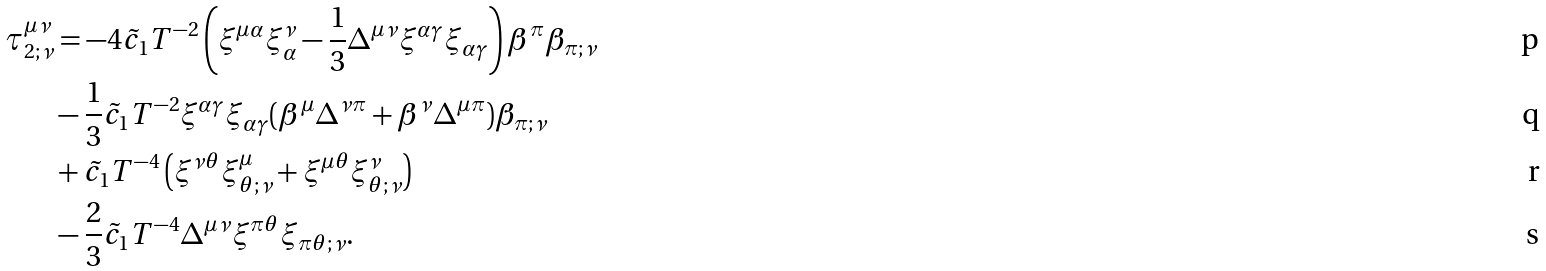<formula> <loc_0><loc_0><loc_500><loc_500>\tau _ { 2 ; \nu } ^ { \mu \nu } & = - 4 \tilde { c } _ { 1 } T ^ { - 2 } \left ( \xi ^ { \mu \alpha } \xi ^ { \nu } _ { \alpha } - \frac { 1 } { 3 } \Delta ^ { \mu \nu } \xi ^ { \alpha \gamma } \xi _ { \alpha \gamma } \right ) \beta ^ { \pi } \beta _ { \pi ; \nu } \\ & - \frac { 1 } { 3 } \tilde { c } _ { 1 } T ^ { - 2 } \xi ^ { \alpha \gamma } \xi _ { \alpha \gamma } ( \beta ^ { \mu } \Delta ^ { \nu \pi } + \beta ^ { \nu } \Delta ^ { \mu \pi } ) \beta _ { \pi ; \nu } \\ & + \tilde { c } _ { 1 } T ^ { - 4 } \left ( \xi ^ { \nu \theta } \xi ^ { \mu } _ { \theta ; \nu } + \xi ^ { \mu \theta } \xi ^ { \nu } _ { \theta ; \nu } \right ) \\ & - \frac { 2 } { 3 } \tilde { c } _ { 1 } T ^ { - 4 } \Delta ^ { \mu \nu } \xi ^ { \pi \theta } \xi _ { \pi \theta ; \nu } .</formula> 